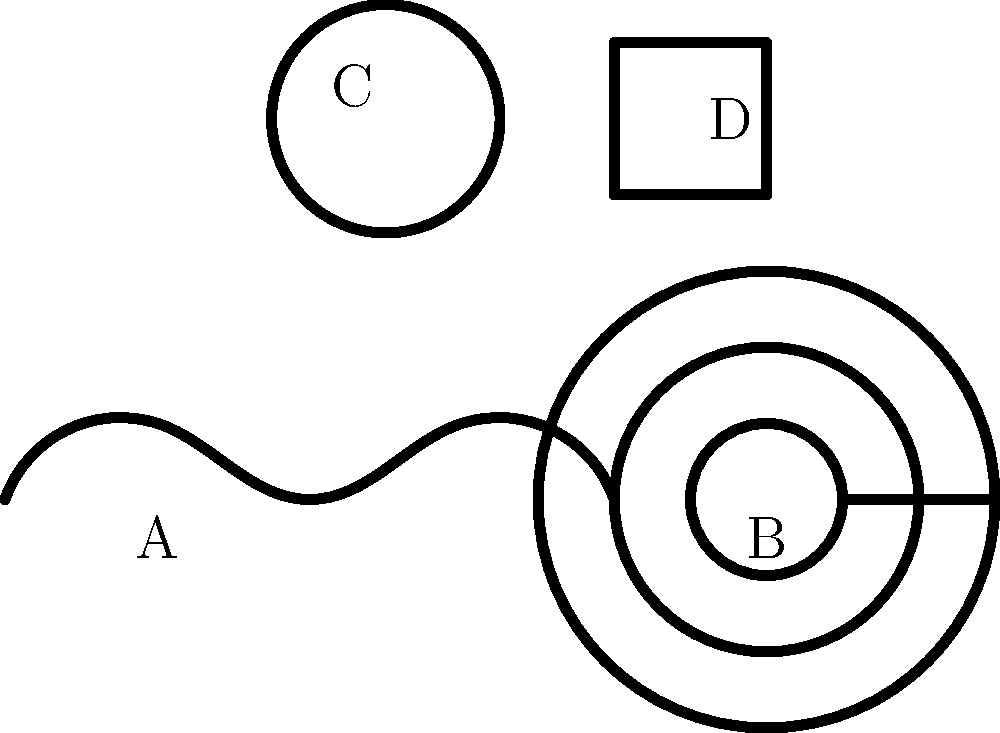In the image above, four traditional Aboriginal symbols are shown. Which symbol represents a waterhole, and what is its spatial relationship to the other symbols? To answer this question, we need to analyze the four symbols present in the image and their spatial relationships:

1. Symbol A: A wavy line, which typically represents a snake or journey in Aboriginal art.
2. Symbol B: Concentric circles, often symbolizing a meeting place or campsite.
3. Symbol C: A single circle, commonly used to represent a waterhole.
4. Symbol D: A U-shaped symbol, usually depicting a person.

The waterhole is represented by Symbol C, the single circle. To describe its spatial relationship to the other symbols:

1. It is located above and to the left of Symbol A (the snake).
2. It is positioned above and to the left of Symbol B (the concentric circles).
3. It is situated to the left of Symbol D (the person).

In terms of the overall composition, the waterhole (Symbol C) is in the upper-left quadrant of the image, centrally positioned among the other symbols.
Answer: Symbol C; upper-left quadrant, centrally positioned 